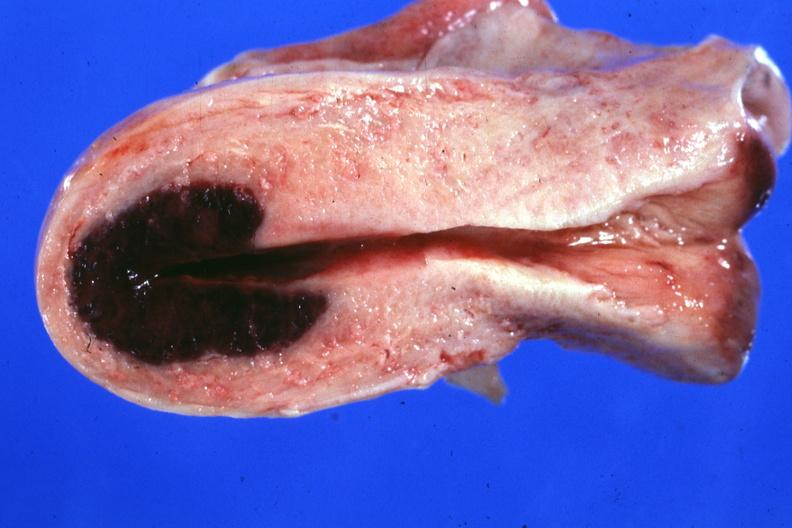s cardiovascular said to have adenosis adenomyosis hemorrhage probably due to shock?
Answer the question using a single word or phrase. No 